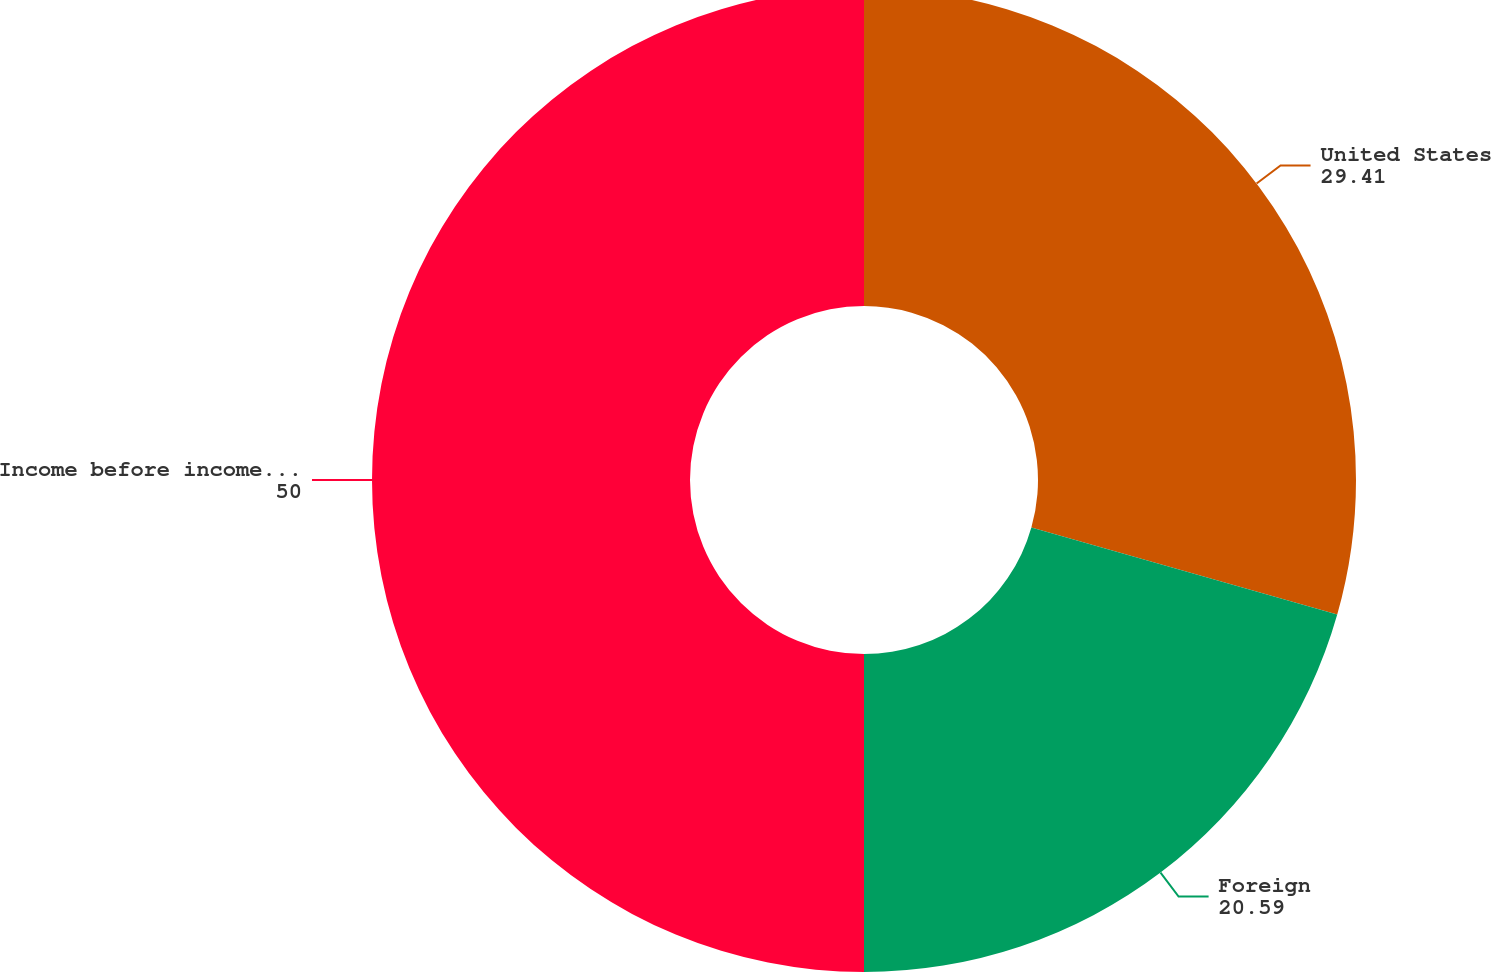Convert chart to OTSL. <chart><loc_0><loc_0><loc_500><loc_500><pie_chart><fcel>United States<fcel>Foreign<fcel>Income before income taxes<nl><fcel>29.41%<fcel>20.59%<fcel>50.0%<nl></chart> 